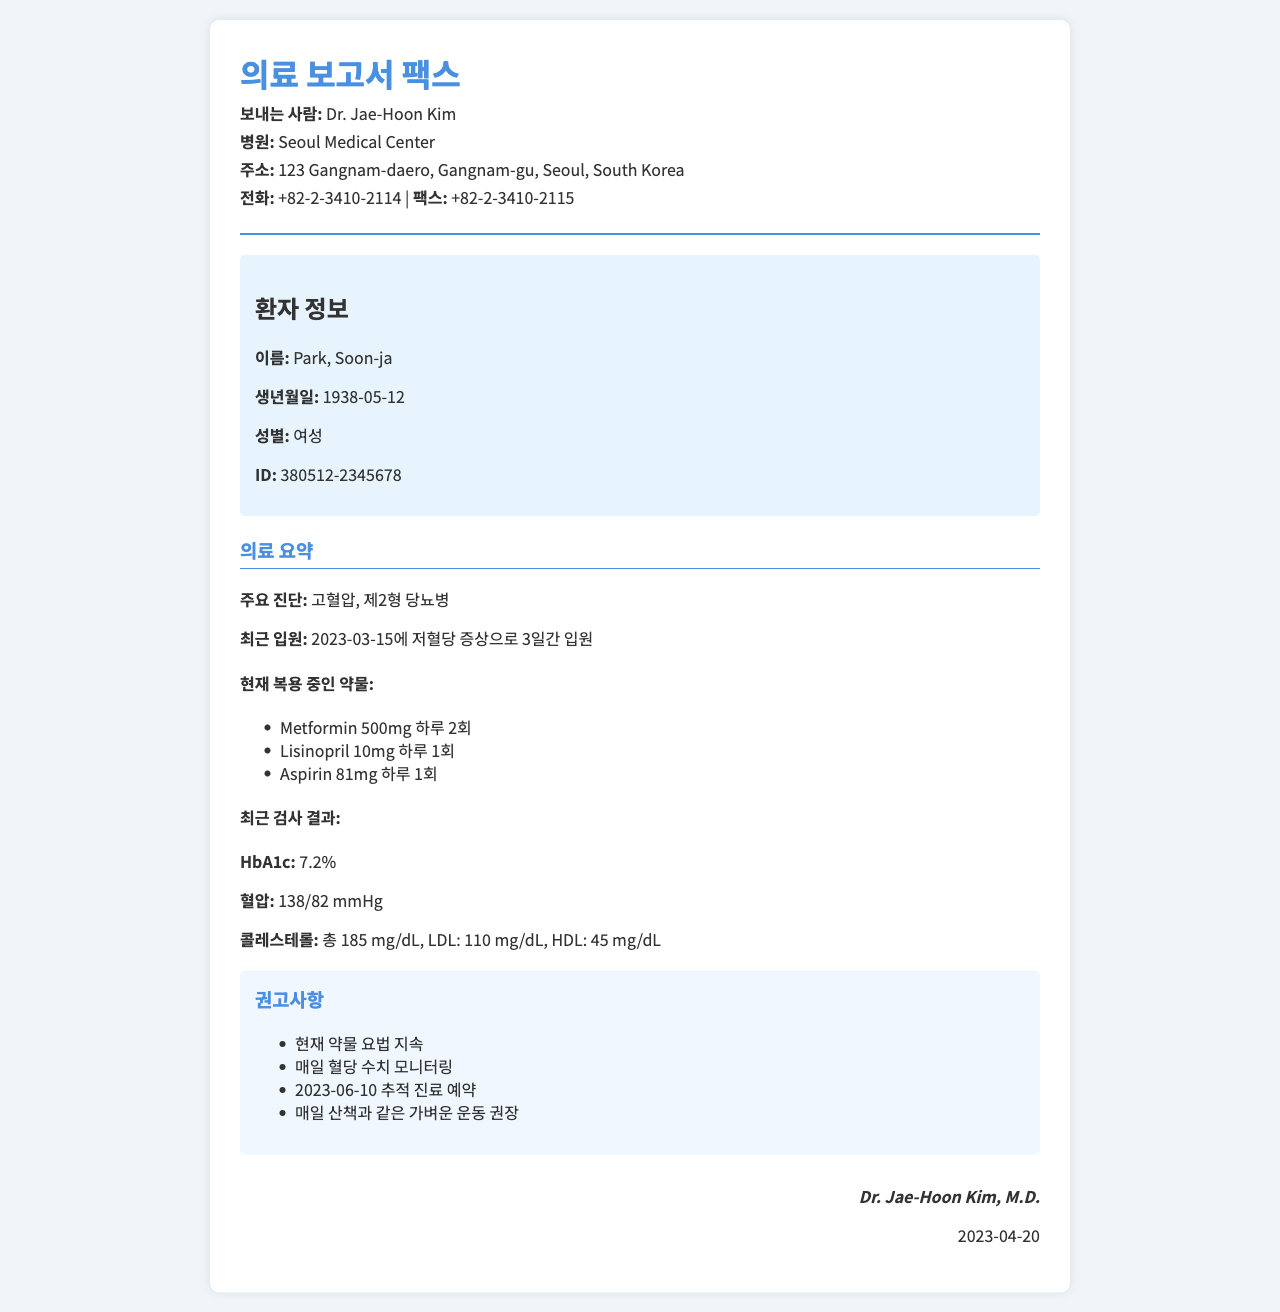what is the name of the patient? The document provides the patient's name in the patient information section.
Answer: Park, Soon-ja what is the date of birth of the patient? The patient's date of birth is mentioned in the patient info section.
Answer: 1938-05-12 who is the doctor that sent the fax? The doctor's name is mentioned at the top in the header section of the document.
Answer: Dr. Jae-Hoon Kim what was the patient hospitalized for? The medical summary indicates the reason for hospitalization in recent medical history.
Answer: 저혈당 증상 what medications is the patient currently taking? The document lists the medications under the medical summary section.
Answer: Metformin 500mg, Lisinopril 10mg, Aspirin 81mg what are the patient's recent cholesterol levels? The document includes cholesterol results in the medical summary section.
Answer: 총 185 mg/dL, LDL: 110 mg/dL, HDL: 45 mg/dL how often should the patient monitor their blood sugar? This recommendation is found in the recommendations section.
Answer: 매일 when is the next follow-up appointment scheduled? The next follow-up appointment date is specified in the recommendations section.
Answer: 2023-06-10 what is the patient's diagnosis? The major diagnoses are provided in the medical summary section.
Answer: 고혈압, 제2형 당뇨병 